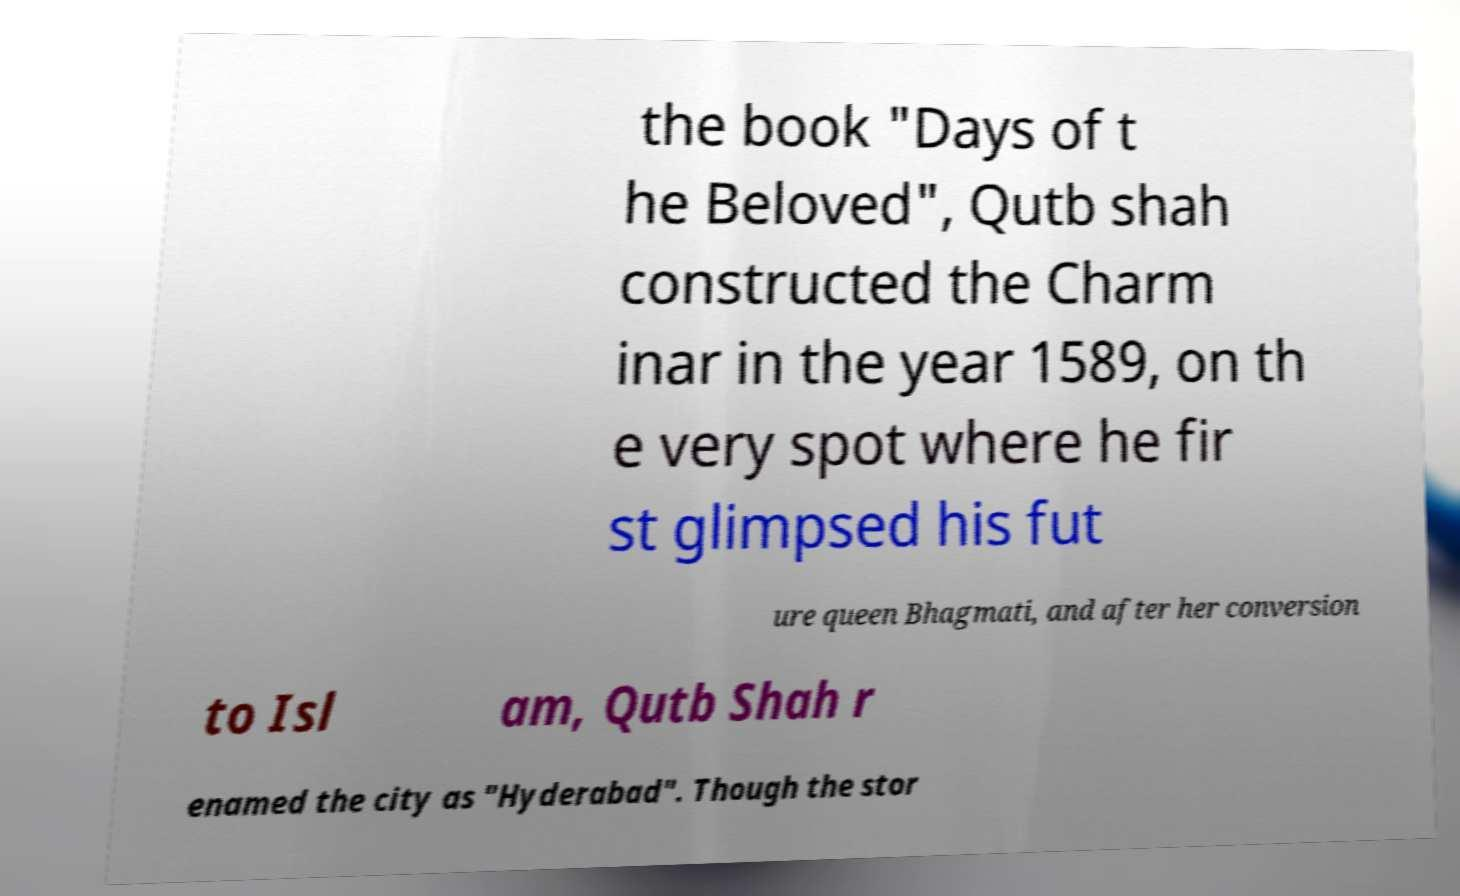Can you accurately transcribe the text from the provided image for me? the book "Days of t he Beloved", Qutb shah constructed the Charm inar in the year 1589, on th e very spot where he fir st glimpsed his fut ure queen Bhagmati, and after her conversion to Isl am, Qutb Shah r enamed the city as "Hyderabad". Though the stor 